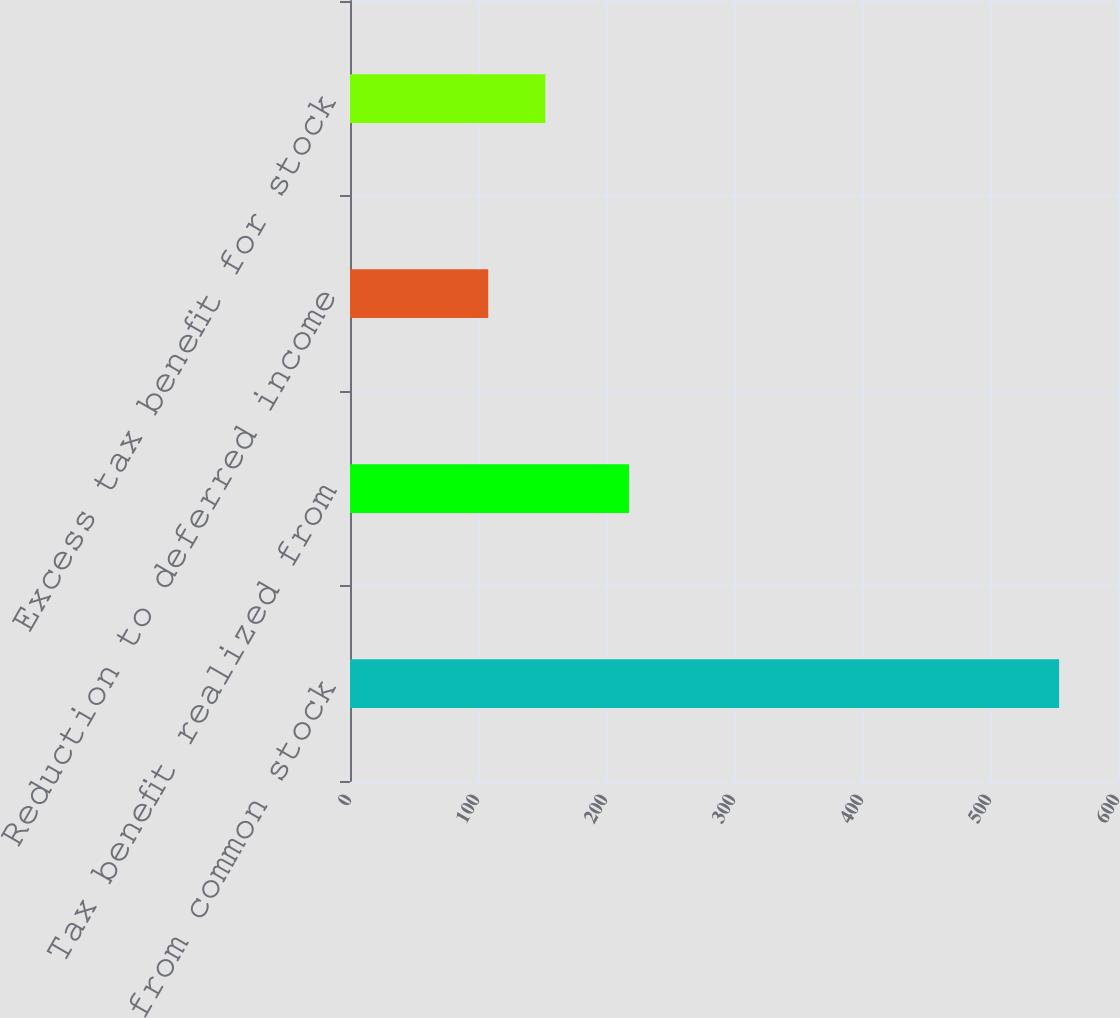Convert chart. <chart><loc_0><loc_0><loc_500><loc_500><bar_chart><fcel>Proceeds from common stock<fcel>Tax benefit realized from<fcel>Reduction to deferred income<fcel>Excess tax benefit for stock<nl><fcel>554<fcel>218<fcel>108<fcel>152.6<nl></chart> 